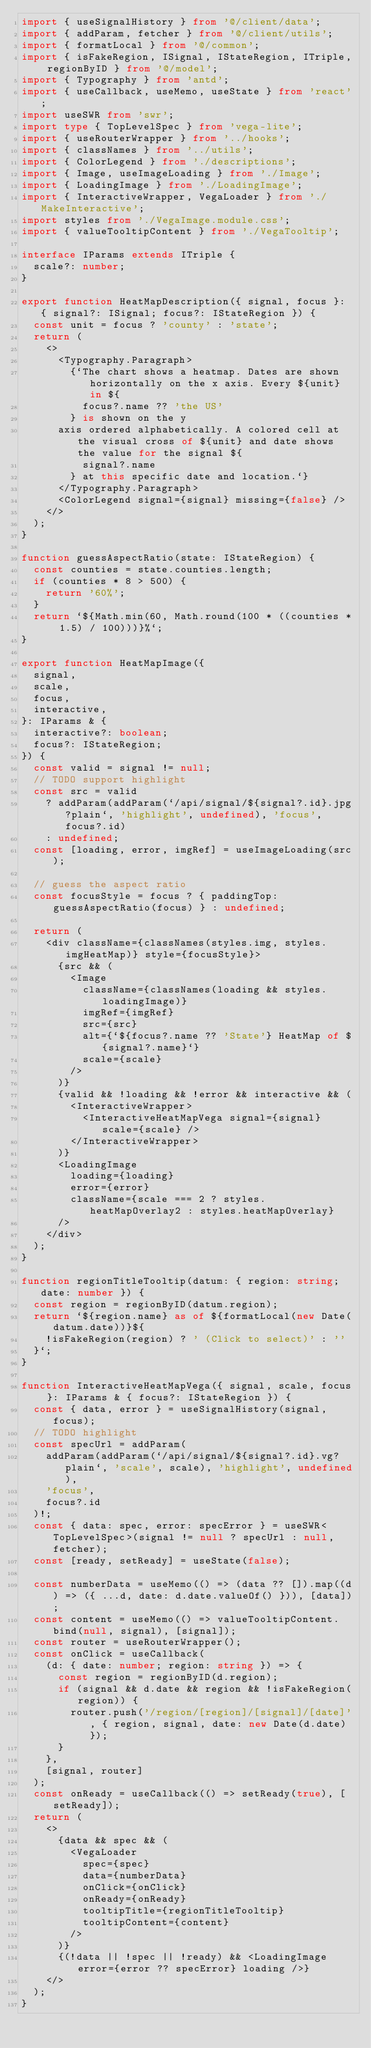Convert code to text. <code><loc_0><loc_0><loc_500><loc_500><_TypeScript_>import { useSignalHistory } from '@/client/data';
import { addParam, fetcher } from '@/client/utils';
import { formatLocal } from '@/common';
import { isFakeRegion, ISignal, IStateRegion, ITriple, regionByID } from '@/model';
import { Typography } from 'antd';
import { useCallback, useMemo, useState } from 'react';
import useSWR from 'swr';
import type { TopLevelSpec } from 'vega-lite';
import { useRouterWrapper } from '../hooks';
import { classNames } from '../utils';
import { ColorLegend } from './descriptions';
import { Image, useImageLoading } from './Image';
import { LoadingImage } from './LoadingImage';
import { InteractiveWrapper, VegaLoader } from './MakeInteractive';
import styles from './VegaImage.module.css';
import { valueTooltipContent } from './VegaTooltip';

interface IParams extends ITriple {
  scale?: number;
}

export function HeatMapDescription({ signal, focus }: { signal?: ISignal; focus?: IStateRegion }) {
  const unit = focus ? 'county' : 'state';
  return (
    <>
      <Typography.Paragraph>
        {`The chart shows a heatmap. Dates are shown horizontally on the x axis. Every ${unit} in ${
          focus?.name ?? 'the US'
        } is shown on the y
      axis ordered alphabetically. A colored cell at the visual cross of ${unit} and date shows the value for the signal ${
          signal?.name
        } at this specific date and location.`}
      </Typography.Paragraph>
      <ColorLegend signal={signal} missing={false} />
    </>
  );
}

function guessAspectRatio(state: IStateRegion) {
  const counties = state.counties.length;
  if (counties * 8 > 500) {
    return '60%';
  }
  return `${Math.min(60, Math.round(100 * ((counties * 1.5) / 100)))}%`;
}

export function HeatMapImage({
  signal,
  scale,
  focus,
  interactive,
}: IParams & {
  interactive?: boolean;
  focus?: IStateRegion;
}) {
  const valid = signal != null;
  // TODO support highlight
  const src = valid
    ? addParam(addParam(`/api/signal/${signal?.id}.jpg?plain`, 'highlight', undefined), 'focus', focus?.id)
    : undefined;
  const [loading, error, imgRef] = useImageLoading(src);

  // guess the aspect ratio
  const focusStyle = focus ? { paddingTop: guessAspectRatio(focus) } : undefined;

  return (
    <div className={classNames(styles.img, styles.imgHeatMap)} style={focusStyle}>
      {src && (
        <Image
          className={classNames(loading && styles.loadingImage)}
          imgRef={imgRef}
          src={src}
          alt={`${focus?.name ?? 'State'} HeatMap of ${signal?.name}`}
          scale={scale}
        />
      )}
      {valid && !loading && !error && interactive && (
        <InteractiveWrapper>
          <InteractiveHeatMapVega signal={signal} scale={scale} />
        </InteractiveWrapper>
      )}
      <LoadingImage
        loading={loading}
        error={error}
        className={scale === 2 ? styles.heatMapOverlay2 : styles.heatMapOverlay}
      />
    </div>
  );
}

function regionTitleTooltip(datum: { region: string; date: number }) {
  const region = regionByID(datum.region);
  return `${region.name} as of ${formatLocal(new Date(datum.date))}${
    !isFakeRegion(region) ? ' (Click to select)' : ''
  }`;
}

function InteractiveHeatMapVega({ signal, scale, focus }: IParams & { focus?: IStateRegion }) {
  const { data, error } = useSignalHistory(signal, focus);
  // TODO highlight
  const specUrl = addParam(
    addParam(addParam(`/api/signal/${signal?.id}.vg?plain`, 'scale', scale), 'highlight', undefined),
    'focus',
    focus?.id
  )!;
  const { data: spec, error: specError } = useSWR<TopLevelSpec>(signal != null ? specUrl : null, fetcher);
  const [ready, setReady] = useState(false);

  const numberData = useMemo(() => (data ?? []).map((d) => ({ ...d, date: d.date.valueOf() })), [data]);
  const content = useMemo(() => valueTooltipContent.bind(null, signal), [signal]);
  const router = useRouterWrapper();
  const onClick = useCallback(
    (d: { date: number; region: string }) => {
      const region = regionByID(d.region);
      if (signal && d.date && region && !isFakeRegion(region)) {
        router.push('/region/[region]/[signal]/[date]', { region, signal, date: new Date(d.date) });
      }
    },
    [signal, router]
  );
  const onReady = useCallback(() => setReady(true), [setReady]);
  return (
    <>
      {data && spec && (
        <VegaLoader
          spec={spec}
          data={numberData}
          onClick={onClick}
          onReady={onReady}
          tooltipTitle={regionTitleTooltip}
          tooltipContent={content}
        />
      )}
      {(!data || !spec || !ready) && <LoadingImage error={error ?? specError} loading />}
    </>
  );
}
</code> 